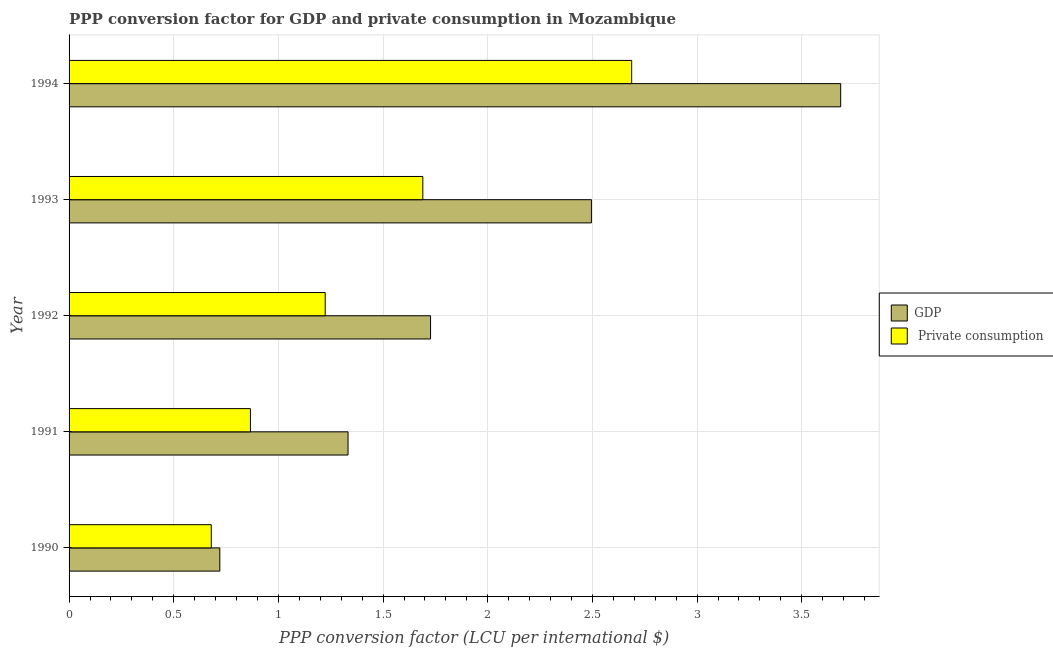Are the number of bars on each tick of the Y-axis equal?
Offer a terse response. Yes. How many bars are there on the 2nd tick from the top?
Offer a very short reply. 2. How many bars are there on the 3rd tick from the bottom?
Make the answer very short. 2. What is the label of the 3rd group of bars from the top?
Ensure brevity in your answer.  1992. What is the ppp conversion factor for private consumption in 1993?
Give a very brief answer. 1.69. Across all years, what is the maximum ppp conversion factor for private consumption?
Ensure brevity in your answer.  2.69. Across all years, what is the minimum ppp conversion factor for gdp?
Give a very brief answer. 0.72. What is the total ppp conversion factor for private consumption in the graph?
Give a very brief answer. 7.15. What is the difference between the ppp conversion factor for gdp in 1991 and that in 1993?
Make the answer very short. -1.16. What is the difference between the ppp conversion factor for private consumption in 1992 and the ppp conversion factor for gdp in 1994?
Ensure brevity in your answer.  -2.46. What is the average ppp conversion factor for private consumption per year?
Your answer should be compact. 1.43. In the year 1992, what is the difference between the ppp conversion factor for private consumption and ppp conversion factor for gdp?
Make the answer very short. -0.5. In how many years, is the ppp conversion factor for private consumption greater than 3 LCU?
Offer a terse response. 0. What is the ratio of the ppp conversion factor for private consumption in 1992 to that in 1994?
Offer a very short reply. 0.46. Is the ppp conversion factor for gdp in 1990 less than that in 1991?
Your answer should be very brief. Yes. Is the difference between the ppp conversion factor for gdp in 1990 and 1991 greater than the difference between the ppp conversion factor for private consumption in 1990 and 1991?
Your answer should be very brief. No. What is the difference between the highest and the second highest ppp conversion factor for private consumption?
Your response must be concise. 1. What is the difference between the highest and the lowest ppp conversion factor for private consumption?
Your answer should be compact. 2.01. Is the sum of the ppp conversion factor for private consumption in 1990 and 1994 greater than the maximum ppp conversion factor for gdp across all years?
Keep it short and to the point. No. What does the 1st bar from the top in 1994 represents?
Your answer should be compact.  Private consumption. What does the 1st bar from the bottom in 1990 represents?
Give a very brief answer. GDP. Are all the bars in the graph horizontal?
Offer a very short reply. Yes. Does the graph contain grids?
Your answer should be compact. Yes. How many legend labels are there?
Make the answer very short. 2. How are the legend labels stacked?
Offer a very short reply. Vertical. What is the title of the graph?
Make the answer very short. PPP conversion factor for GDP and private consumption in Mozambique. What is the label or title of the X-axis?
Make the answer very short. PPP conversion factor (LCU per international $). What is the label or title of the Y-axis?
Make the answer very short. Year. What is the PPP conversion factor (LCU per international $) in GDP in 1990?
Make the answer very short. 0.72. What is the PPP conversion factor (LCU per international $) in  Private consumption in 1990?
Make the answer very short. 0.68. What is the PPP conversion factor (LCU per international $) of GDP in 1991?
Offer a terse response. 1.33. What is the PPP conversion factor (LCU per international $) of  Private consumption in 1991?
Offer a terse response. 0.87. What is the PPP conversion factor (LCU per international $) in GDP in 1992?
Keep it short and to the point. 1.73. What is the PPP conversion factor (LCU per international $) in  Private consumption in 1992?
Offer a very short reply. 1.22. What is the PPP conversion factor (LCU per international $) in GDP in 1993?
Offer a very short reply. 2.5. What is the PPP conversion factor (LCU per international $) in  Private consumption in 1993?
Your answer should be compact. 1.69. What is the PPP conversion factor (LCU per international $) in GDP in 1994?
Provide a succinct answer. 3.69. What is the PPP conversion factor (LCU per international $) in  Private consumption in 1994?
Offer a very short reply. 2.69. Across all years, what is the maximum PPP conversion factor (LCU per international $) in GDP?
Offer a terse response. 3.69. Across all years, what is the maximum PPP conversion factor (LCU per international $) of  Private consumption?
Offer a terse response. 2.69. Across all years, what is the minimum PPP conversion factor (LCU per international $) of GDP?
Offer a very short reply. 0.72. Across all years, what is the minimum PPP conversion factor (LCU per international $) of  Private consumption?
Your answer should be compact. 0.68. What is the total PPP conversion factor (LCU per international $) in GDP in the graph?
Make the answer very short. 9.96. What is the total PPP conversion factor (LCU per international $) in  Private consumption in the graph?
Provide a short and direct response. 7.15. What is the difference between the PPP conversion factor (LCU per international $) of GDP in 1990 and that in 1991?
Your answer should be compact. -0.61. What is the difference between the PPP conversion factor (LCU per international $) of  Private consumption in 1990 and that in 1991?
Offer a very short reply. -0.19. What is the difference between the PPP conversion factor (LCU per international $) of GDP in 1990 and that in 1992?
Provide a succinct answer. -1.01. What is the difference between the PPP conversion factor (LCU per international $) of  Private consumption in 1990 and that in 1992?
Your answer should be very brief. -0.54. What is the difference between the PPP conversion factor (LCU per international $) of GDP in 1990 and that in 1993?
Ensure brevity in your answer.  -1.78. What is the difference between the PPP conversion factor (LCU per international $) of  Private consumption in 1990 and that in 1993?
Your answer should be very brief. -1.01. What is the difference between the PPP conversion factor (LCU per international $) in GDP in 1990 and that in 1994?
Offer a terse response. -2.97. What is the difference between the PPP conversion factor (LCU per international $) in  Private consumption in 1990 and that in 1994?
Your answer should be compact. -2.01. What is the difference between the PPP conversion factor (LCU per international $) of GDP in 1991 and that in 1992?
Ensure brevity in your answer.  -0.39. What is the difference between the PPP conversion factor (LCU per international $) of  Private consumption in 1991 and that in 1992?
Provide a short and direct response. -0.36. What is the difference between the PPP conversion factor (LCU per international $) in GDP in 1991 and that in 1993?
Give a very brief answer. -1.16. What is the difference between the PPP conversion factor (LCU per international $) in  Private consumption in 1991 and that in 1993?
Make the answer very short. -0.82. What is the difference between the PPP conversion factor (LCU per international $) of GDP in 1991 and that in 1994?
Offer a very short reply. -2.35. What is the difference between the PPP conversion factor (LCU per international $) in  Private consumption in 1991 and that in 1994?
Your response must be concise. -1.82. What is the difference between the PPP conversion factor (LCU per international $) in GDP in 1992 and that in 1993?
Your response must be concise. -0.77. What is the difference between the PPP conversion factor (LCU per international $) in  Private consumption in 1992 and that in 1993?
Offer a very short reply. -0.47. What is the difference between the PPP conversion factor (LCU per international $) in GDP in 1992 and that in 1994?
Give a very brief answer. -1.96. What is the difference between the PPP conversion factor (LCU per international $) in  Private consumption in 1992 and that in 1994?
Offer a terse response. -1.46. What is the difference between the PPP conversion factor (LCU per international $) of GDP in 1993 and that in 1994?
Your answer should be very brief. -1.19. What is the difference between the PPP conversion factor (LCU per international $) of  Private consumption in 1993 and that in 1994?
Your answer should be compact. -1. What is the difference between the PPP conversion factor (LCU per international $) of GDP in 1990 and the PPP conversion factor (LCU per international $) of  Private consumption in 1991?
Give a very brief answer. -0.15. What is the difference between the PPP conversion factor (LCU per international $) of GDP in 1990 and the PPP conversion factor (LCU per international $) of  Private consumption in 1992?
Your answer should be compact. -0.5. What is the difference between the PPP conversion factor (LCU per international $) of GDP in 1990 and the PPP conversion factor (LCU per international $) of  Private consumption in 1993?
Provide a short and direct response. -0.97. What is the difference between the PPP conversion factor (LCU per international $) of GDP in 1990 and the PPP conversion factor (LCU per international $) of  Private consumption in 1994?
Ensure brevity in your answer.  -1.97. What is the difference between the PPP conversion factor (LCU per international $) of GDP in 1991 and the PPP conversion factor (LCU per international $) of  Private consumption in 1992?
Your response must be concise. 0.11. What is the difference between the PPP conversion factor (LCU per international $) in GDP in 1991 and the PPP conversion factor (LCU per international $) in  Private consumption in 1993?
Your answer should be very brief. -0.36. What is the difference between the PPP conversion factor (LCU per international $) of GDP in 1991 and the PPP conversion factor (LCU per international $) of  Private consumption in 1994?
Provide a short and direct response. -1.35. What is the difference between the PPP conversion factor (LCU per international $) in GDP in 1992 and the PPP conversion factor (LCU per international $) in  Private consumption in 1993?
Provide a succinct answer. 0.04. What is the difference between the PPP conversion factor (LCU per international $) in GDP in 1992 and the PPP conversion factor (LCU per international $) in  Private consumption in 1994?
Provide a short and direct response. -0.96. What is the difference between the PPP conversion factor (LCU per international $) of GDP in 1993 and the PPP conversion factor (LCU per international $) of  Private consumption in 1994?
Provide a short and direct response. -0.19. What is the average PPP conversion factor (LCU per international $) in GDP per year?
Offer a terse response. 1.99. What is the average PPP conversion factor (LCU per international $) in  Private consumption per year?
Offer a terse response. 1.43. In the year 1990, what is the difference between the PPP conversion factor (LCU per international $) in GDP and PPP conversion factor (LCU per international $) in  Private consumption?
Make the answer very short. 0.04. In the year 1991, what is the difference between the PPP conversion factor (LCU per international $) in GDP and PPP conversion factor (LCU per international $) in  Private consumption?
Give a very brief answer. 0.47. In the year 1992, what is the difference between the PPP conversion factor (LCU per international $) in GDP and PPP conversion factor (LCU per international $) in  Private consumption?
Your response must be concise. 0.5. In the year 1993, what is the difference between the PPP conversion factor (LCU per international $) of GDP and PPP conversion factor (LCU per international $) of  Private consumption?
Ensure brevity in your answer.  0.81. In the year 1994, what is the difference between the PPP conversion factor (LCU per international $) of GDP and PPP conversion factor (LCU per international $) of  Private consumption?
Make the answer very short. 1. What is the ratio of the PPP conversion factor (LCU per international $) in GDP in 1990 to that in 1991?
Your answer should be compact. 0.54. What is the ratio of the PPP conversion factor (LCU per international $) in  Private consumption in 1990 to that in 1991?
Your response must be concise. 0.78. What is the ratio of the PPP conversion factor (LCU per international $) in GDP in 1990 to that in 1992?
Make the answer very short. 0.42. What is the ratio of the PPP conversion factor (LCU per international $) of  Private consumption in 1990 to that in 1992?
Offer a terse response. 0.56. What is the ratio of the PPP conversion factor (LCU per international $) in GDP in 1990 to that in 1993?
Your answer should be compact. 0.29. What is the ratio of the PPP conversion factor (LCU per international $) in  Private consumption in 1990 to that in 1993?
Give a very brief answer. 0.4. What is the ratio of the PPP conversion factor (LCU per international $) in GDP in 1990 to that in 1994?
Your response must be concise. 0.2. What is the ratio of the PPP conversion factor (LCU per international $) in  Private consumption in 1990 to that in 1994?
Provide a succinct answer. 0.25. What is the ratio of the PPP conversion factor (LCU per international $) in GDP in 1991 to that in 1992?
Offer a very short reply. 0.77. What is the ratio of the PPP conversion factor (LCU per international $) in  Private consumption in 1991 to that in 1992?
Provide a succinct answer. 0.71. What is the ratio of the PPP conversion factor (LCU per international $) of GDP in 1991 to that in 1993?
Ensure brevity in your answer.  0.53. What is the ratio of the PPP conversion factor (LCU per international $) in  Private consumption in 1991 to that in 1993?
Make the answer very short. 0.51. What is the ratio of the PPP conversion factor (LCU per international $) in GDP in 1991 to that in 1994?
Your answer should be compact. 0.36. What is the ratio of the PPP conversion factor (LCU per international $) in  Private consumption in 1991 to that in 1994?
Your answer should be compact. 0.32. What is the ratio of the PPP conversion factor (LCU per international $) of GDP in 1992 to that in 1993?
Offer a very short reply. 0.69. What is the ratio of the PPP conversion factor (LCU per international $) of  Private consumption in 1992 to that in 1993?
Give a very brief answer. 0.72. What is the ratio of the PPP conversion factor (LCU per international $) of GDP in 1992 to that in 1994?
Give a very brief answer. 0.47. What is the ratio of the PPP conversion factor (LCU per international $) of  Private consumption in 1992 to that in 1994?
Your response must be concise. 0.46. What is the ratio of the PPP conversion factor (LCU per international $) in GDP in 1993 to that in 1994?
Keep it short and to the point. 0.68. What is the ratio of the PPP conversion factor (LCU per international $) in  Private consumption in 1993 to that in 1994?
Offer a terse response. 0.63. What is the difference between the highest and the second highest PPP conversion factor (LCU per international $) in GDP?
Provide a succinct answer. 1.19. What is the difference between the highest and the second highest PPP conversion factor (LCU per international $) of  Private consumption?
Ensure brevity in your answer.  1. What is the difference between the highest and the lowest PPP conversion factor (LCU per international $) in GDP?
Provide a succinct answer. 2.97. What is the difference between the highest and the lowest PPP conversion factor (LCU per international $) of  Private consumption?
Provide a short and direct response. 2.01. 